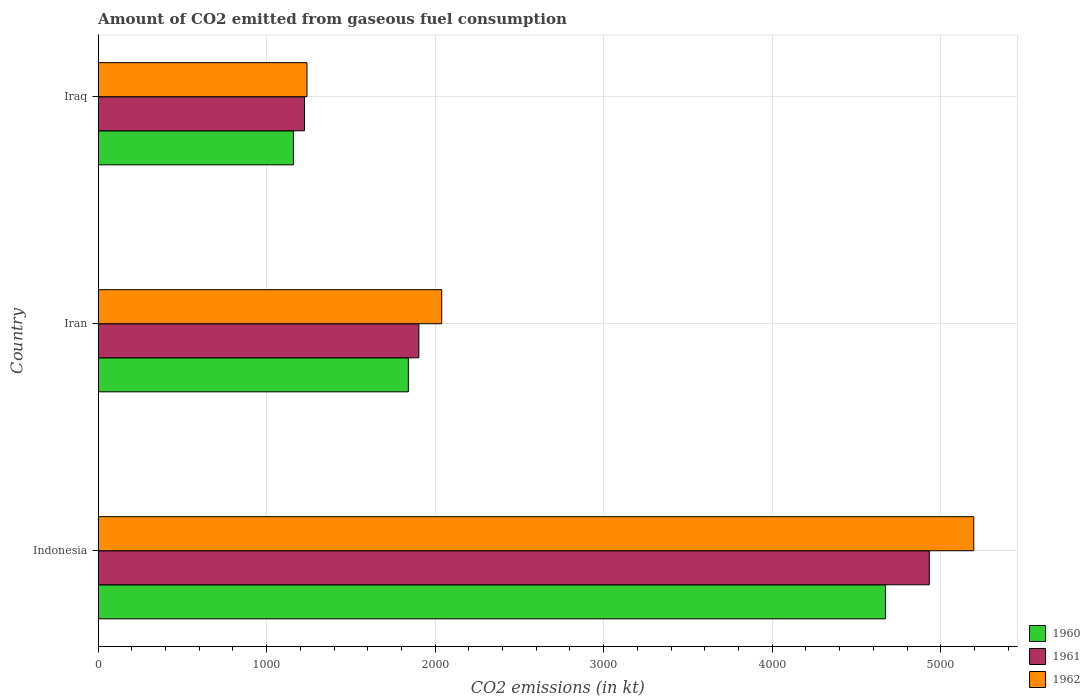Are the number of bars on each tick of the Y-axis equal?
Keep it short and to the point. Yes. How many bars are there on the 1st tick from the top?
Offer a very short reply. 3. What is the label of the 2nd group of bars from the top?
Ensure brevity in your answer.  Iran. What is the amount of CO2 emitted in 1961 in Iraq?
Your response must be concise. 1224.78. Across all countries, what is the maximum amount of CO2 emitted in 1962?
Keep it short and to the point. 5196.14. Across all countries, what is the minimum amount of CO2 emitted in 1960?
Your response must be concise. 1158.77. In which country was the amount of CO2 emitted in 1962 maximum?
Your answer should be compact. Indonesia. In which country was the amount of CO2 emitted in 1960 minimum?
Offer a very short reply. Iraq. What is the total amount of CO2 emitted in 1962 in the graph?
Provide a succinct answer. 8474.44. What is the difference between the amount of CO2 emitted in 1960 in Iran and that in Iraq?
Your response must be concise. 682.06. What is the difference between the amount of CO2 emitted in 1960 in Iran and the amount of CO2 emitted in 1961 in Indonesia?
Ensure brevity in your answer.  -3091.28. What is the average amount of CO2 emitted in 1962 per country?
Provide a succinct answer. 2824.81. What is the difference between the amount of CO2 emitted in 1962 and amount of CO2 emitted in 1961 in Iran?
Your answer should be very brief. 135.68. What is the ratio of the amount of CO2 emitted in 1962 in Indonesia to that in Iraq?
Provide a short and direct response. 4.19. Is the difference between the amount of CO2 emitted in 1962 in Indonesia and Iraq greater than the difference between the amount of CO2 emitted in 1961 in Indonesia and Iraq?
Ensure brevity in your answer.  Yes. What is the difference between the highest and the second highest amount of CO2 emitted in 1961?
Provide a succinct answer. 3028.94. What is the difference between the highest and the lowest amount of CO2 emitted in 1960?
Give a very brief answer. 3512.99. Is the sum of the amount of CO2 emitted in 1961 in Indonesia and Iraq greater than the maximum amount of CO2 emitted in 1960 across all countries?
Make the answer very short. Yes. What does the 3rd bar from the top in Iran represents?
Keep it short and to the point. 1960. How many bars are there?
Ensure brevity in your answer.  9. Are all the bars in the graph horizontal?
Offer a very short reply. Yes. What is the title of the graph?
Keep it short and to the point. Amount of CO2 emitted from gaseous fuel consumption. What is the label or title of the X-axis?
Give a very brief answer. CO2 emissions (in kt). What is the label or title of the Y-axis?
Your answer should be compact. Country. What is the CO2 emissions (in kt) in 1960 in Indonesia?
Give a very brief answer. 4671.76. What is the CO2 emissions (in kt) in 1961 in Indonesia?
Offer a terse response. 4932.11. What is the CO2 emissions (in kt) in 1962 in Indonesia?
Offer a terse response. 5196.14. What is the CO2 emissions (in kt) of 1960 in Iran?
Make the answer very short. 1840.83. What is the CO2 emissions (in kt) of 1961 in Iran?
Offer a very short reply. 1903.17. What is the CO2 emissions (in kt) of 1962 in Iran?
Your answer should be very brief. 2038.85. What is the CO2 emissions (in kt) in 1960 in Iraq?
Provide a short and direct response. 1158.77. What is the CO2 emissions (in kt) of 1961 in Iraq?
Make the answer very short. 1224.78. What is the CO2 emissions (in kt) in 1962 in Iraq?
Provide a short and direct response. 1239.45. Across all countries, what is the maximum CO2 emissions (in kt) of 1960?
Your answer should be compact. 4671.76. Across all countries, what is the maximum CO2 emissions (in kt) of 1961?
Keep it short and to the point. 4932.11. Across all countries, what is the maximum CO2 emissions (in kt) of 1962?
Ensure brevity in your answer.  5196.14. Across all countries, what is the minimum CO2 emissions (in kt) in 1960?
Your answer should be very brief. 1158.77. Across all countries, what is the minimum CO2 emissions (in kt) in 1961?
Make the answer very short. 1224.78. Across all countries, what is the minimum CO2 emissions (in kt) in 1962?
Your response must be concise. 1239.45. What is the total CO2 emissions (in kt) of 1960 in the graph?
Provide a succinct answer. 7671.36. What is the total CO2 emissions (in kt) of 1961 in the graph?
Provide a short and direct response. 8060.07. What is the total CO2 emissions (in kt) of 1962 in the graph?
Provide a succinct answer. 8474.44. What is the difference between the CO2 emissions (in kt) in 1960 in Indonesia and that in Iran?
Ensure brevity in your answer.  2830.92. What is the difference between the CO2 emissions (in kt) of 1961 in Indonesia and that in Iran?
Ensure brevity in your answer.  3028.94. What is the difference between the CO2 emissions (in kt) in 1962 in Indonesia and that in Iran?
Offer a terse response. 3157.29. What is the difference between the CO2 emissions (in kt) of 1960 in Indonesia and that in Iraq?
Your answer should be very brief. 3512.99. What is the difference between the CO2 emissions (in kt) in 1961 in Indonesia and that in Iraq?
Make the answer very short. 3707.34. What is the difference between the CO2 emissions (in kt) of 1962 in Indonesia and that in Iraq?
Provide a succinct answer. 3956.69. What is the difference between the CO2 emissions (in kt) of 1960 in Iran and that in Iraq?
Your answer should be very brief. 682.06. What is the difference between the CO2 emissions (in kt) in 1961 in Iran and that in Iraq?
Keep it short and to the point. 678.39. What is the difference between the CO2 emissions (in kt) of 1962 in Iran and that in Iraq?
Offer a terse response. 799.41. What is the difference between the CO2 emissions (in kt) in 1960 in Indonesia and the CO2 emissions (in kt) in 1961 in Iran?
Provide a succinct answer. 2768.59. What is the difference between the CO2 emissions (in kt) of 1960 in Indonesia and the CO2 emissions (in kt) of 1962 in Iran?
Make the answer very short. 2632.91. What is the difference between the CO2 emissions (in kt) in 1961 in Indonesia and the CO2 emissions (in kt) in 1962 in Iran?
Ensure brevity in your answer.  2893.26. What is the difference between the CO2 emissions (in kt) in 1960 in Indonesia and the CO2 emissions (in kt) in 1961 in Iraq?
Offer a very short reply. 3446.98. What is the difference between the CO2 emissions (in kt) of 1960 in Indonesia and the CO2 emissions (in kt) of 1962 in Iraq?
Offer a terse response. 3432.31. What is the difference between the CO2 emissions (in kt) of 1961 in Indonesia and the CO2 emissions (in kt) of 1962 in Iraq?
Make the answer very short. 3692.67. What is the difference between the CO2 emissions (in kt) of 1960 in Iran and the CO2 emissions (in kt) of 1961 in Iraq?
Give a very brief answer. 616.06. What is the difference between the CO2 emissions (in kt) in 1960 in Iran and the CO2 emissions (in kt) in 1962 in Iraq?
Offer a very short reply. 601.39. What is the difference between the CO2 emissions (in kt) of 1961 in Iran and the CO2 emissions (in kt) of 1962 in Iraq?
Ensure brevity in your answer.  663.73. What is the average CO2 emissions (in kt) in 1960 per country?
Give a very brief answer. 2557.12. What is the average CO2 emissions (in kt) in 1961 per country?
Give a very brief answer. 2686.69. What is the average CO2 emissions (in kt) in 1962 per country?
Provide a short and direct response. 2824.81. What is the difference between the CO2 emissions (in kt) in 1960 and CO2 emissions (in kt) in 1961 in Indonesia?
Offer a very short reply. -260.36. What is the difference between the CO2 emissions (in kt) in 1960 and CO2 emissions (in kt) in 1962 in Indonesia?
Your answer should be compact. -524.38. What is the difference between the CO2 emissions (in kt) in 1961 and CO2 emissions (in kt) in 1962 in Indonesia?
Give a very brief answer. -264.02. What is the difference between the CO2 emissions (in kt) in 1960 and CO2 emissions (in kt) in 1961 in Iran?
Make the answer very short. -62.34. What is the difference between the CO2 emissions (in kt) of 1960 and CO2 emissions (in kt) of 1962 in Iran?
Offer a very short reply. -198.02. What is the difference between the CO2 emissions (in kt) of 1961 and CO2 emissions (in kt) of 1962 in Iran?
Your answer should be very brief. -135.68. What is the difference between the CO2 emissions (in kt) in 1960 and CO2 emissions (in kt) in 1961 in Iraq?
Keep it short and to the point. -66.01. What is the difference between the CO2 emissions (in kt) in 1960 and CO2 emissions (in kt) in 1962 in Iraq?
Keep it short and to the point. -80.67. What is the difference between the CO2 emissions (in kt) of 1961 and CO2 emissions (in kt) of 1962 in Iraq?
Your answer should be very brief. -14.67. What is the ratio of the CO2 emissions (in kt) of 1960 in Indonesia to that in Iran?
Keep it short and to the point. 2.54. What is the ratio of the CO2 emissions (in kt) in 1961 in Indonesia to that in Iran?
Your response must be concise. 2.59. What is the ratio of the CO2 emissions (in kt) of 1962 in Indonesia to that in Iran?
Provide a succinct answer. 2.55. What is the ratio of the CO2 emissions (in kt) in 1960 in Indonesia to that in Iraq?
Your answer should be very brief. 4.03. What is the ratio of the CO2 emissions (in kt) of 1961 in Indonesia to that in Iraq?
Make the answer very short. 4.03. What is the ratio of the CO2 emissions (in kt) of 1962 in Indonesia to that in Iraq?
Keep it short and to the point. 4.19. What is the ratio of the CO2 emissions (in kt) of 1960 in Iran to that in Iraq?
Your answer should be compact. 1.59. What is the ratio of the CO2 emissions (in kt) of 1961 in Iran to that in Iraq?
Keep it short and to the point. 1.55. What is the ratio of the CO2 emissions (in kt) of 1962 in Iran to that in Iraq?
Your answer should be very brief. 1.65. What is the difference between the highest and the second highest CO2 emissions (in kt) in 1960?
Ensure brevity in your answer.  2830.92. What is the difference between the highest and the second highest CO2 emissions (in kt) in 1961?
Offer a very short reply. 3028.94. What is the difference between the highest and the second highest CO2 emissions (in kt) of 1962?
Your answer should be compact. 3157.29. What is the difference between the highest and the lowest CO2 emissions (in kt) in 1960?
Provide a succinct answer. 3512.99. What is the difference between the highest and the lowest CO2 emissions (in kt) of 1961?
Offer a terse response. 3707.34. What is the difference between the highest and the lowest CO2 emissions (in kt) in 1962?
Your response must be concise. 3956.69. 